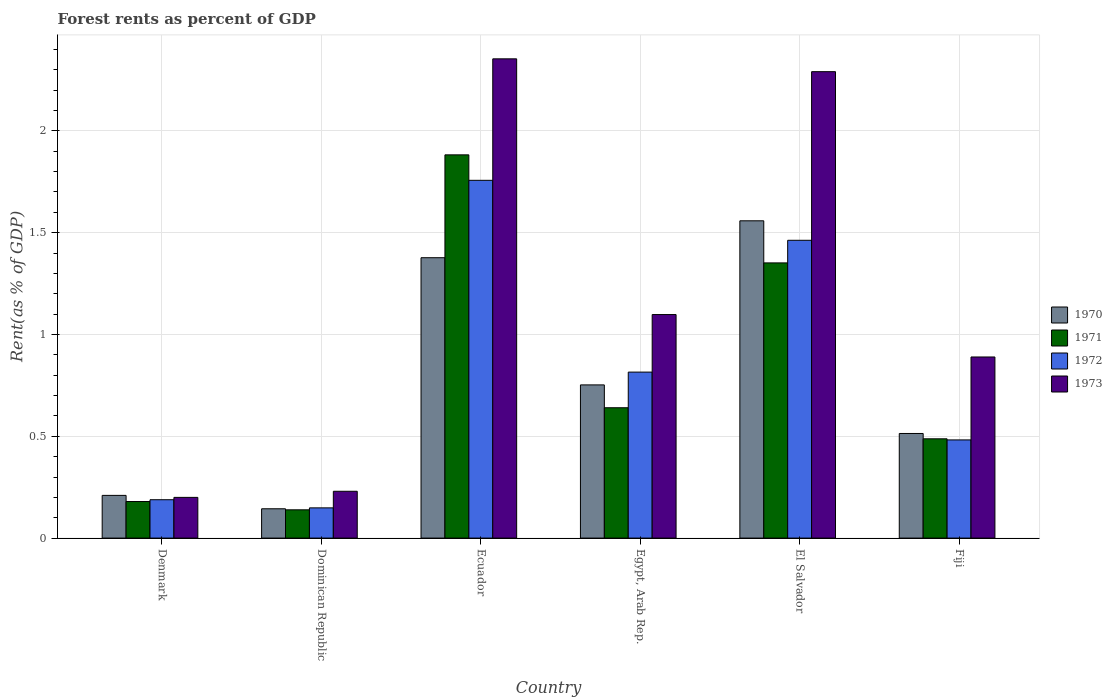How many different coloured bars are there?
Provide a succinct answer. 4. Are the number of bars per tick equal to the number of legend labels?
Provide a succinct answer. Yes. Are the number of bars on each tick of the X-axis equal?
Keep it short and to the point. Yes. How many bars are there on the 4th tick from the left?
Your response must be concise. 4. What is the label of the 3rd group of bars from the left?
Provide a short and direct response. Ecuador. What is the forest rent in 1970 in El Salvador?
Offer a very short reply. 1.56. Across all countries, what is the maximum forest rent in 1973?
Make the answer very short. 2.35. Across all countries, what is the minimum forest rent in 1972?
Give a very brief answer. 0.15. In which country was the forest rent in 1970 maximum?
Give a very brief answer. El Salvador. In which country was the forest rent in 1972 minimum?
Offer a terse response. Dominican Republic. What is the total forest rent in 1970 in the graph?
Provide a short and direct response. 4.56. What is the difference between the forest rent in 1973 in Dominican Republic and that in Fiji?
Keep it short and to the point. -0.66. What is the difference between the forest rent in 1973 in Denmark and the forest rent in 1970 in Egypt, Arab Rep.?
Offer a terse response. -0.55. What is the average forest rent in 1970 per country?
Keep it short and to the point. 0.76. What is the difference between the forest rent of/in 1970 and forest rent of/in 1971 in Ecuador?
Ensure brevity in your answer.  -0.51. In how many countries, is the forest rent in 1973 greater than 1.8 %?
Provide a short and direct response. 2. What is the ratio of the forest rent in 1970 in Ecuador to that in Fiji?
Give a very brief answer. 2.68. Is the difference between the forest rent in 1970 in Ecuador and Egypt, Arab Rep. greater than the difference between the forest rent in 1971 in Ecuador and Egypt, Arab Rep.?
Your answer should be compact. No. What is the difference between the highest and the second highest forest rent in 1971?
Provide a succinct answer. -1.24. What is the difference between the highest and the lowest forest rent in 1970?
Your answer should be compact. 1.41. In how many countries, is the forest rent in 1973 greater than the average forest rent in 1973 taken over all countries?
Offer a terse response. 2. Is the sum of the forest rent in 1970 in Denmark and Dominican Republic greater than the maximum forest rent in 1972 across all countries?
Make the answer very short. No. What does the 4th bar from the left in Denmark represents?
Your answer should be very brief. 1973. How many bars are there?
Your response must be concise. 24. How many countries are there in the graph?
Your answer should be very brief. 6. What is the difference between two consecutive major ticks on the Y-axis?
Give a very brief answer. 0.5. Does the graph contain any zero values?
Keep it short and to the point. No. Does the graph contain grids?
Provide a short and direct response. Yes. Where does the legend appear in the graph?
Offer a very short reply. Center right. How many legend labels are there?
Your answer should be compact. 4. How are the legend labels stacked?
Your answer should be very brief. Vertical. What is the title of the graph?
Your answer should be compact. Forest rents as percent of GDP. What is the label or title of the X-axis?
Your response must be concise. Country. What is the label or title of the Y-axis?
Provide a short and direct response. Rent(as % of GDP). What is the Rent(as % of GDP) in 1970 in Denmark?
Keep it short and to the point. 0.21. What is the Rent(as % of GDP) in 1971 in Denmark?
Keep it short and to the point. 0.18. What is the Rent(as % of GDP) of 1972 in Denmark?
Your answer should be very brief. 0.19. What is the Rent(as % of GDP) in 1973 in Denmark?
Offer a very short reply. 0.2. What is the Rent(as % of GDP) in 1970 in Dominican Republic?
Offer a very short reply. 0.14. What is the Rent(as % of GDP) of 1971 in Dominican Republic?
Offer a terse response. 0.14. What is the Rent(as % of GDP) in 1972 in Dominican Republic?
Provide a short and direct response. 0.15. What is the Rent(as % of GDP) of 1973 in Dominican Republic?
Provide a short and direct response. 0.23. What is the Rent(as % of GDP) of 1970 in Ecuador?
Offer a terse response. 1.38. What is the Rent(as % of GDP) in 1971 in Ecuador?
Make the answer very short. 1.88. What is the Rent(as % of GDP) in 1972 in Ecuador?
Offer a very short reply. 1.76. What is the Rent(as % of GDP) of 1973 in Ecuador?
Your answer should be very brief. 2.35. What is the Rent(as % of GDP) of 1970 in Egypt, Arab Rep.?
Your answer should be very brief. 0.75. What is the Rent(as % of GDP) of 1971 in Egypt, Arab Rep.?
Keep it short and to the point. 0.64. What is the Rent(as % of GDP) of 1972 in Egypt, Arab Rep.?
Keep it short and to the point. 0.82. What is the Rent(as % of GDP) in 1973 in Egypt, Arab Rep.?
Ensure brevity in your answer.  1.1. What is the Rent(as % of GDP) in 1970 in El Salvador?
Your answer should be compact. 1.56. What is the Rent(as % of GDP) of 1971 in El Salvador?
Provide a succinct answer. 1.35. What is the Rent(as % of GDP) in 1972 in El Salvador?
Your answer should be very brief. 1.46. What is the Rent(as % of GDP) in 1973 in El Salvador?
Offer a terse response. 2.29. What is the Rent(as % of GDP) in 1970 in Fiji?
Your response must be concise. 0.51. What is the Rent(as % of GDP) in 1971 in Fiji?
Provide a succinct answer. 0.49. What is the Rent(as % of GDP) of 1972 in Fiji?
Give a very brief answer. 0.48. What is the Rent(as % of GDP) in 1973 in Fiji?
Offer a terse response. 0.89. Across all countries, what is the maximum Rent(as % of GDP) of 1970?
Offer a terse response. 1.56. Across all countries, what is the maximum Rent(as % of GDP) of 1971?
Keep it short and to the point. 1.88. Across all countries, what is the maximum Rent(as % of GDP) of 1972?
Your response must be concise. 1.76. Across all countries, what is the maximum Rent(as % of GDP) of 1973?
Provide a short and direct response. 2.35. Across all countries, what is the minimum Rent(as % of GDP) of 1970?
Offer a terse response. 0.14. Across all countries, what is the minimum Rent(as % of GDP) in 1971?
Offer a very short reply. 0.14. Across all countries, what is the minimum Rent(as % of GDP) of 1972?
Make the answer very short. 0.15. Across all countries, what is the minimum Rent(as % of GDP) in 1973?
Keep it short and to the point. 0.2. What is the total Rent(as % of GDP) in 1970 in the graph?
Keep it short and to the point. 4.56. What is the total Rent(as % of GDP) in 1971 in the graph?
Offer a terse response. 4.68. What is the total Rent(as % of GDP) of 1972 in the graph?
Your answer should be very brief. 4.85. What is the total Rent(as % of GDP) in 1973 in the graph?
Ensure brevity in your answer.  7.06. What is the difference between the Rent(as % of GDP) in 1970 in Denmark and that in Dominican Republic?
Provide a short and direct response. 0.07. What is the difference between the Rent(as % of GDP) of 1971 in Denmark and that in Dominican Republic?
Your answer should be compact. 0.04. What is the difference between the Rent(as % of GDP) in 1972 in Denmark and that in Dominican Republic?
Give a very brief answer. 0.04. What is the difference between the Rent(as % of GDP) in 1973 in Denmark and that in Dominican Republic?
Give a very brief answer. -0.03. What is the difference between the Rent(as % of GDP) of 1970 in Denmark and that in Ecuador?
Your answer should be compact. -1.17. What is the difference between the Rent(as % of GDP) of 1971 in Denmark and that in Ecuador?
Provide a short and direct response. -1.7. What is the difference between the Rent(as % of GDP) of 1972 in Denmark and that in Ecuador?
Your response must be concise. -1.57. What is the difference between the Rent(as % of GDP) of 1973 in Denmark and that in Ecuador?
Your response must be concise. -2.15. What is the difference between the Rent(as % of GDP) in 1970 in Denmark and that in Egypt, Arab Rep.?
Provide a short and direct response. -0.54. What is the difference between the Rent(as % of GDP) of 1971 in Denmark and that in Egypt, Arab Rep.?
Ensure brevity in your answer.  -0.46. What is the difference between the Rent(as % of GDP) in 1972 in Denmark and that in Egypt, Arab Rep.?
Your answer should be very brief. -0.63. What is the difference between the Rent(as % of GDP) in 1973 in Denmark and that in Egypt, Arab Rep.?
Offer a terse response. -0.9. What is the difference between the Rent(as % of GDP) of 1970 in Denmark and that in El Salvador?
Provide a succinct answer. -1.35. What is the difference between the Rent(as % of GDP) in 1971 in Denmark and that in El Salvador?
Provide a succinct answer. -1.17. What is the difference between the Rent(as % of GDP) in 1972 in Denmark and that in El Salvador?
Your answer should be compact. -1.27. What is the difference between the Rent(as % of GDP) in 1973 in Denmark and that in El Salvador?
Your answer should be compact. -2.09. What is the difference between the Rent(as % of GDP) in 1970 in Denmark and that in Fiji?
Provide a short and direct response. -0.3. What is the difference between the Rent(as % of GDP) in 1971 in Denmark and that in Fiji?
Give a very brief answer. -0.31. What is the difference between the Rent(as % of GDP) in 1972 in Denmark and that in Fiji?
Offer a very short reply. -0.29. What is the difference between the Rent(as % of GDP) of 1973 in Denmark and that in Fiji?
Offer a very short reply. -0.69. What is the difference between the Rent(as % of GDP) of 1970 in Dominican Republic and that in Ecuador?
Give a very brief answer. -1.23. What is the difference between the Rent(as % of GDP) in 1971 in Dominican Republic and that in Ecuador?
Make the answer very short. -1.74. What is the difference between the Rent(as % of GDP) of 1972 in Dominican Republic and that in Ecuador?
Make the answer very short. -1.61. What is the difference between the Rent(as % of GDP) of 1973 in Dominican Republic and that in Ecuador?
Give a very brief answer. -2.12. What is the difference between the Rent(as % of GDP) of 1970 in Dominican Republic and that in Egypt, Arab Rep.?
Offer a terse response. -0.61. What is the difference between the Rent(as % of GDP) of 1971 in Dominican Republic and that in Egypt, Arab Rep.?
Offer a terse response. -0.5. What is the difference between the Rent(as % of GDP) of 1972 in Dominican Republic and that in Egypt, Arab Rep.?
Your response must be concise. -0.67. What is the difference between the Rent(as % of GDP) in 1973 in Dominican Republic and that in Egypt, Arab Rep.?
Offer a terse response. -0.87. What is the difference between the Rent(as % of GDP) of 1970 in Dominican Republic and that in El Salvador?
Your answer should be compact. -1.41. What is the difference between the Rent(as % of GDP) in 1971 in Dominican Republic and that in El Salvador?
Your answer should be compact. -1.21. What is the difference between the Rent(as % of GDP) in 1972 in Dominican Republic and that in El Salvador?
Ensure brevity in your answer.  -1.31. What is the difference between the Rent(as % of GDP) of 1973 in Dominican Republic and that in El Salvador?
Provide a short and direct response. -2.06. What is the difference between the Rent(as % of GDP) of 1970 in Dominican Republic and that in Fiji?
Provide a succinct answer. -0.37. What is the difference between the Rent(as % of GDP) in 1971 in Dominican Republic and that in Fiji?
Offer a terse response. -0.35. What is the difference between the Rent(as % of GDP) in 1972 in Dominican Republic and that in Fiji?
Your answer should be very brief. -0.33. What is the difference between the Rent(as % of GDP) in 1973 in Dominican Republic and that in Fiji?
Provide a short and direct response. -0.66. What is the difference between the Rent(as % of GDP) in 1970 in Ecuador and that in Egypt, Arab Rep.?
Your answer should be very brief. 0.62. What is the difference between the Rent(as % of GDP) of 1971 in Ecuador and that in Egypt, Arab Rep.?
Your answer should be compact. 1.24. What is the difference between the Rent(as % of GDP) of 1972 in Ecuador and that in Egypt, Arab Rep.?
Offer a terse response. 0.94. What is the difference between the Rent(as % of GDP) in 1973 in Ecuador and that in Egypt, Arab Rep.?
Make the answer very short. 1.26. What is the difference between the Rent(as % of GDP) of 1970 in Ecuador and that in El Salvador?
Provide a succinct answer. -0.18. What is the difference between the Rent(as % of GDP) in 1971 in Ecuador and that in El Salvador?
Offer a very short reply. 0.53. What is the difference between the Rent(as % of GDP) in 1972 in Ecuador and that in El Salvador?
Keep it short and to the point. 0.29. What is the difference between the Rent(as % of GDP) of 1973 in Ecuador and that in El Salvador?
Offer a very short reply. 0.06. What is the difference between the Rent(as % of GDP) of 1970 in Ecuador and that in Fiji?
Offer a very short reply. 0.86. What is the difference between the Rent(as % of GDP) of 1971 in Ecuador and that in Fiji?
Offer a terse response. 1.39. What is the difference between the Rent(as % of GDP) in 1972 in Ecuador and that in Fiji?
Your response must be concise. 1.28. What is the difference between the Rent(as % of GDP) of 1973 in Ecuador and that in Fiji?
Your response must be concise. 1.46. What is the difference between the Rent(as % of GDP) in 1970 in Egypt, Arab Rep. and that in El Salvador?
Provide a short and direct response. -0.81. What is the difference between the Rent(as % of GDP) in 1971 in Egypt, Arab Rep. and that in El Salvador?
Keep it short and to the point. -0.71. What is the difference between the Rent(as % of GDP) in 1972 in Egypt, Arab Rep. and that in El Salvador?
Give a very brief answer. -0.65. What is the difference between the Rent(as % of GDP) of 1973 in Egypt, Arab Rep. and that in El Salvador?
Keep it short and to the point. -1.19. What is the difference between the Rent(as % of GDP) of 1970 in Egypt, Arab Rep. and that in Fiji?
Your response must be concise. 0.24. What is the difference between the Rent(as % of GDP) in 1971 in Egypt, Arab Rep. and that in Fiji?
Offer a terse response. 0.15. What is the difference between the Rent(as % of GDP) in 1972 in Egypt, Arab Rep. and that in Fiji?
Give a very brief answer. 0.33. What is the difference between the Rent(as % of GDP) of 1973 in Egypt, Arab Rep. and that in Fiji?
Your answer should be very brief. 0.21. What is the difference between the Rent(as % of GDP) of 1970 in El Salvador and that in Fiji?
Give a very brief answer. 1.04. What is the difference between the Rent(as % of GDP) of 1971 in El Salvador and that in Fiji?
Give a very brief answer. 0.86. What is the difference between the Rent(as % of GDP) of 1972 in El Salvador and that in Fiji?
Ensure brevity in your answer.  0.98. What is the difference between the Rent(as % of GDP) of 1973 in El Salvador and that in Fiji?
Keep it short and to the point. 1.4. What is the difference between the Rent(as % of GDP) in 1970 in Denmark and the Rent(as % of GDP) in 1971 in Dominican Republic?
Your answer should be compact. 0.07. What is the difference between the Rent(as % of GDP) of 1970 in Denmark and the Rent(as % of GDP) of 1972 in Dominican Republic?
Make the answer very short. 0.06. What is the difference between the Rent(as % of GDP) of 1970 in Denmark and the Rent(as % of GDP) of 1973 in Dominican Republic?
Provide a succinct answer. -0.02. What is the difference between the Rent(as % of GDP) in 1971 in Denmark and the Rent(as % of GDP) in 1972 in Dominican Republic?
Your response must be concise. 0.03. What is the difference between the Rent(as % of GDP) in 1971 in Denmark and the Rent(as % of GDP) in 1973 in Dominican Republic?
Offer a terse response. -0.05. What is the difference between the Rent(as % of GDP) of 1972 in Denmark and the Rent(as % of GDP) of 1973 in Dominican Republic?
Your answer should be compact. -0.04. What is the difference between the Rent(as % of GDP) in 1970 in Denmark and the Rent(as % of GDP) in 1971 in Ecuador?
Offer a very short reply. -1.67. What is the difference between the Rent(as % of GDP) in 1970 in Denmark and the Rent(as % of GDP) in 1972 in Ecuador?
Provide a short and direct response. -1.55. What is the difference between the Rent(as % of GDP) in 1970 in Denmark and the Rent(as % of GDP) in 1973 in Ecuador?
Provide a succinct answer. -2.14. What is the difference between the Rent(as % of GDP) in 1971 in Denmark and the Rent(as % of GDP) in 1972 in Ecuador?
Offer a very short reply. -1.58. What is the difference between the Rent(as % of GDP) in 1971 in Denmark and the Rent(as % of GDP) in 1973 in Ecuador?
Keep it short and to the point. -2.17. What is the difference between the Rent(as % of GDP) of 1972 in Denmark and the Rent(as % of GDP) of 1973 in Ecuador?
Offer a terse response. -2.17. What is the difference between the Rent(as % of GDP) of 1970 in Denmark and the Rent(as % of GDP) of 1971 in Egypt, Arab Rep.?
Offer a very short reply. -0.43. What is the difference between the Rent(as % of GDP) of 1970 in Denmark and the Rent(as % of GDP) of 1972 in Egypt, Arab Rep.?
Ensure brevity in your answer.  -0.61. What is the difference between the Rent(as % of GDP) in 1970 in Denmark and the Rent(as % of GDP) in 1973 in Egypt, Arab Rep.?
Keep it short and to the point. -0.89. What is the difference between the Rent(as % of GDP) in 1971 in Denmark and the Rent(as % of GDP) in 1972 in Egypt, Arab Rep.?
Offer a very short reply. -0.64. What is the difference between the Rent(as % of GDP) in 1971 in Denmark and the Rent(as % of GDP) in 1973 in Egypt, Arab Rep.?
Provide a short and direct response. -0.92. What is the difference between the Rent(as % of GDP) of 1972 in Denmark and the Rent(as % of GDP) of 1973 in Egypt, Arab Rep.?
Provide a short and direct response. -0.91. What is the difference between the Rent(as % of GDP) in 1970 in Denmark and the Rent(as % of GDP) in 1971 in El Salvador?
Ensure brevity in your answer.  -1.14. What is the difference between the Rent(as % of GDP) in 1970 in Denmark and the Rent(as % of GDP) in 1972 in El Salvador?
Provide a succinct answer. -1.25. What is the difference between the Rent(as % of GDP) in 1970 in Denmark and the Rent(as % of GDP) in 1973 in El Salvador?
Offer a very short reply. -2.08. What is the difference between the Rent(as % of GDP) in 1971 in Denmark and the Rent(as % of GDP) in 1972 in El Salvador?
Your answer should be compact. -1.28. What is the difference between the Rent(as % of GDP) in 1971 in Denmark and the Rent(as % of GDP) in 1973 in El Salvador?
Provide a succinct answer. -2.11. What is the difference between the Rent(as % of GDP) in 1972 in Denmark and the Rent(as % of GDP) in 1973 in El Salvador?
Give a very brief answer. -2.1. What is the difference between the Rent(as % of GDP) in 1970 in Denmark and the Rent(as % of GDP) in 1971 in Fiji?
Keep it short and to the point. -0.28. What is the difference between the Rent(as % of GDP) of 1970 in Denmark and the Rent(as % of GDP) of 1972 in Fiji?
Make the answer very short. -0.27. What is the difference between the Rent(as % of GDP) of 1970 in Denmark and the Rent(as % of GDP) of 1973 in Fiji?
Your answer should be very brief. -0.68. What is the difference between the Rent(as % of GDP) in 1971 in Denmark and the Rent(as % of GDP) in 1972 in Fiji?
Your answer should be very brief. -0.3. What is the difference between the Rent(as % of GDP) in 1971 in Denmark and the Rent(as % of GDP) in 1973 in Fiji?
Make the answer very short. -0.71. What is the difference between the Rent(as % of GDP) of 1972 in Denmark and the Rent(as % of GDP) of 1973 in Fiji?
Make the answer very short. -0.7. What is the difference between the Rent(as % of GDP) of 1970 in Dominican Republic and the Rent(as % of GDP) of 1971 in Ecuador?
Offer a very short reply. -1.74. What is the difference between the Rent(as % of GDP) of 1970 in Dominican Republic and the Rent(as % of GDP) of 1972 in Ecuador?
Your answer should be compact. -1.61. What is the difference between the Rent(as % of GDP) of 1970 in Dominican Republic and the Rent(as % of GDP) of 1973 in Ecuador?
Provide a succinct answer. -2.21. What is the difference between the Rent(as % of GDP) of 1971 in Dominican Republic and the Rent(as % of GDP) of 1972 in Ecuador?
Your answer should be very brief. -1.62. What is the difference between the Rent(as % of GDP) of 1971 in Dominican Republic and the Rent(as % of GDP) of 1973 in Ecuador?
Give a very brief answer. -2.22. What is the difference between the Rent(as % of GDP) in 1972 in Dominican Republic and the Rent(as % of GDP) in 1973 in Ecuador?
Provide a short and direct response. -2.21. What is the difference between the Rent(as % of GDP) of 1970 in Dominican Republic and the Rent(as % of GDP) of 1971 in Egypt, Arab Rep.?
Offer a terse response. -0.5. What is the difference between the Rent(as % of GDP) in 1970 in Dominican Republic and the Rent(as % of GDP) in 1972 in Egypt, Arab Rep.?
Ensure brevity in your answer.  -0.67. What is the difference between the Rent(as % of GDP) in 1970 in Dominican Republic and the Rent(as % of GDP) in 1973 in Egypt, Arab Rep.?
Your response must be concise. -0.95. What is the difference between the Rent(as % of GDP) of 1971 in Dominican Republic and the Rent(as % of GDP) of 1972 in Egypt, Arab Rep.?
Give a very brief answer. -0.68. What is the difference between the Rent(as % of GDP) in 1971 in Dominican Republic and the Rent(as % of GDP) in 1973 in Egypt, Arab Rep.?
Offer a terse response. -0.96. What is the difference between the Rent(as % of GDP) of 1972 in Dominican Republic and the Rent(as % of GDP) of 1973 in Egypt, Arab Rep.?
Your response must be concise. -0.95. What is the difference between the Rent(as % of GDP) in 1970 in Dominican Republic and the Rent(as % of GDP) in 1971 in El Salvador?
Provide a short and direct response. -1.21. What is the difference between the Rent(as % of GDP) in 1970 in Dominican Republic and the Rent(as % of GDP) in 1972 in El Salvador?
Provide a succinct answer. -1.32. What is the difference between the Rent(as % of GDP) in 1970 in Dominican Republic and the Rent(as % of GDP) in 1973 in El Salvador?
Make the answer very short. -2.15. What is the difference between the Rent(as % of GDP) of 1971 in Dominican Republic and the Rent(as % of GDP) of 1972 in El Salvador?
Provide a succinct answer. -1.32. What is the difference between the Rent(as % of GDP) of 1971 in Dominican Republic and the Rent(as % of GDP) of 1973 in El Salvador?
Provide a succinct answer. -2.15. What is the difference between the Rent(as % of GDP) in 1972 in Dominican Republic and the Rent(as % of GDP) in 1973 in El Salvador?
Your answer should be compact. -2.14. What is the difference between the Rent(as % of GDP) of 1970 in Dominican Republic and the Rent(as % of GDP) of 1971 in Fiji?
Offer a terse response. -0.34. What is the difference between the Rent(as % of GDP) of 1970 in Dominican Republic and the Rent(as % of GDP) of 1972 in Fiji?
Provide a succinct answer. -0.34. What is the difference between the Rent(as % of GDP) in 1970 in Dominican Republic and the Rent(as % of GDP) in 1973 in Fiji?
Provide a succinct answer. -0.75. What is the difference between the Rent(as % of GDP) of 1971 in Dominican Republic and the Rent(as % of GDP) of 1972 in Fiji?
Provide a succinct answer. -0.34. What is the difference between the Rent(as % of GDP) of 1971 in Dominican Republic and the Rent(as % of GDP) of 1973 in Fiji?
Offer a terse response. -0.75. What is the difference between the Rent(as % of GDP) of 1972 in Dominican Republic and the Rent(as % of GDP) of 1973 in Fiji?
Ensure brevity in your answer.  -0.74. What is the difference between the Rent(as % of GDP) in 1970 in Ecuador and the Rent(as % of GDP) in 1971 in Egypt, Arab Rep.?
Give a very brief answer. 0.74. What is the difference between the Rent(as % of GDP) in 1970 in Ecuador and the Rent(as % of GDP) in 1972 in Egypt, Arab Rep.?
Provide a short and direct response. 0.56. What is the difference between the Rent(as % of GDP) in 1970 in Ecuador and the Rent(as % of GDP) in 1973 in Egypt, Arab Rep.?
Your response must be concise. 0.28. What is the difference between the Rent(as % of GDP) in 1971 in Ecuador and the Rent(as % of GDP) in 1972 in Egypt, Arab Rep.?
Your response must be concise. 1.07. What is the difference between the Rent(as % of GDP) in 1971 in Ecuador and the Rent(as % of GDP) in 1973 in Egypt, Arab Rep.?
Offer a terse response. 0.78. What is the difference between the Rent(as % of GDP) of 1972 in Ecuador and the Rent(as % of GDP) of 1973 in Egypt, Arab Rep.?
Your response must be concise. 0.66. What is the difference between the Rent(as % of GDP) in 1970 in Ecuador and the Rent(as % of GDP) in 1971 in El Salvador?
Your answer should be compact. 0.03. What is the difference between the Rent(as % of GDP) in 1970 in Ecuador and the Rent(as % of GDP) in 1972 in El Salvador?
Make the answer very short. -0.09. What is the difference between the Rent(as % of GDP) in 1970 in Ecuador and the Rent(as % of GDP) in 1973 in El Salvador?
Ensure brevity in your answer.  -0.91. What is the difference between the Rent(as % of GDP) of 1971 in Ecuador and the Rent(as % of GDP) of 1972 in El Salvador?
Your response must be concise. 0.42. What is the difference between the Rent(as % of GDP) of 1971 in Ecuador and the Rent(as % of GDP) of 1973 in El Salvador?
Offer a very short reply. -0.41. What is the difference between the Rent(as % of GDP) in 1972 in Ecuador and the Rent(as % of GDP) in 1973 in El Salvador?
Ensure brevity in your answer.  -0.53. What is the difference between the Rent(as % of GDP) in 1970 in Ecuador and the Rent(as % of GDP) in 1971 in Fiji?
Offer a terse response. 0.89. What is the difference between the Rent(as % of GDP) in 1970 in Ecuador and the Rent(as % of GDP) in 1972 in Fiji?
Offer a very short reply. 0.89. What is the difference between the Rent(as % of GDP) of 1970 in Ecuador and the Rent(as % of GDP) of 1973 in Fiji?
Your response must be concise. 0.49. What is the difference between the Rent(as % of GDP) of 1971 in Ecuador and the Rent(as % of GDP) of 1972 in Fiji?
Your answer should be compact. 1.4. What is the difference between the Rent(as % of GDP) in 1972 in Ecuador and the Rent(as % of GDP) in 1973 in Fiji?
Your response must be concise. 0.87. What is the difference between the Rent(as % of GDP) in 1970 in Egypt, Arab Rep. and the Rent(as % of GDP) in 1971 in El Salvador?
Give a very brief answer. -0.6. What is the difference between the Rent(as % of GDP) of 1970 in Egypt, Arab Rep. and the Rent(as % of GDP) of 1972 in El Salvador?
Offer a terse response. -0.71. What is the difference between the Rent(as % of GDP) in 1970 in Egypt, Arab Rep. and the Rent(as % of GDP) in 1973 in El Salvador?
Provide a short and direct response. -1.54. What is the difference between the Rent(as % of GDP) in 1971 in Egypt, Arab Rep. and the Rent(as % of GDP) in 1972 in El Salvador?
Give a very brief answer. -0.82. What is the difference between the Rent(as % of GDP) in 1971 in Egypt, Arab Rep. and the Rent(as % of GDP) in 1973 in El Salvador?
Ensure brevity in your answer.  -1.65. What is the difference between the Rent(as % of GDP) in 1972 in Egypt, Arab Rep. and the Rent(as % of GDP) in 1973 in El Salvador?
Make the answer very short. -1.48. What is the difference between the Rent(as % of GDP) of 1970 in Egypt, Arab Rep. and the Rent(as % of GDP) of 1971 in Fiji?
Your response must be concise. 0.26. What is the difference between the Rent(as % of GDP) of 1970 in Egypt, Arab Rep. and the Rent(as % of GDP) of 1972 in Fiji?
Make the answer very short. 0.27. What is the difference between the Rent(as % of GDP) of 1970 in Egypt, Arab Rep. and the Rent(as % of GDP) of 1973 in Fiji?
Keep it short and to the point. -0.14. What is the difference between the Rent(as % of GDP) in 1971 in Egypt, Arab Rep. and the Rent(as % of GDP) in 1972 in Fiji?
Provide a short and direct response. 0.16. What is the difference between the Rent(as % of GDP) in 1971 in Egypt, Arab Rep. and the Rent(as % of GDP) in 1973 in Fiji?
Give a very brief answer. -0.25. What is the difference between the Rent(as % of GDP) in 1972 in Egypt, Arab Rep. and the Rent(as % of GDP) in 1973 in Fiji?
Offer a very short reply. -0.07. What is the difference between the Rent(as % of GDP) in 1970 in El Salvador and the Rent(as % of GDP) in 1971 in Fiji?
Provide a succinct answer. 1.07. What is the difference between the Rent(as % of GDP) in 1970 in El Salvador and the Rent(as % of GDP) in 1972 in Fiji?
Make the answer very short. 1.08. What is the difference between the Rent(as % of GDP) in 1970 in El Salvador and the Rent(as % of GDP) in 1973 in Fiji?
Make the answer very short. 0.67. What is the difference between the Rent(as % of GDP) of 1971 in El Salvador and the Rent(as % of GDP) of 1972 in Fiji?
Give a very brief answer. 0.87. What is the difference between the Rent(as % of GDP) in 1971 in El Salvador and the Rent(as % of GDP) in 1973 in Fiji?
Your answer should be very brief. 0.46. What is the difference between the Rent(as % of GDP) of 1972 in El Salvador and the Rent(as % of GDP) of 1973 in Fiji?
Ensure brevity in your answer.  0.57. What is the average Rent(as % of GDP) in 1970 per country?
Provide a succinct answer. 0.76. What is the average Rent(as % of GDP) of 1971 per country?
Provide a succinct answer. 0.78. What is the average Rent(as % of GDP) in 1972 per country?
Ensure brevity in your answer.  0.81. What is the average Rent(as % of GDP) of 1973 per country?
Keep it short and to the point. 1.18. What is the difference between the Rent(as % of GDP) of 1970 and Rent(as % of GDP) of 1971 in Denmark?
Your response must be concise. 0.03. What is the difference between the Rent(as % of GDP) of 1970 and Rent(as % of GDP) of 1972 in Denmark?
Provide a short and direct response. 0.02. What is the difference between the Rent(as % of GDP) of 1970 and Rent(as % of GDP) of 1973 in Denmark?
Provide a succinct answer. 0.01. What is the difference between the Rent(as % of GDP) of 1971 and Rent(as % of GDP) of 1972 in Denmark?
Your response must be concise. -0.01. What is the difference between the Rent(as % of GDP) in 1971 and Rent(as % of GDP) in 1973 in Denmark?
Provide a succinct answer. -0.02. What is the difference between the Rent(as % of GDP) of 1972 and Rent(as % of GDP) of 1973 in Denmark?
Your response must be concise. -0.01. What is the difference between the Rent(as % of GDP) of 1970 and Rent(as % of GDP) of 1971 in Dominican Republic?
Provide a short and direct response. 0.01. What is the difference between the Rent(as % of GDP) in 1970 and Rent(as % of GDP) in 1972 in Dominican Republic?
Offer a terse response. -0. What is the difference between the Rent(as % of GDP) of 1970 and Rent(as % of GDP) of 1973 in Dominican Republic?
Provide a succinct answer. -0.09. What is the difference between the Rent(as % of GDP) in 1971 and Rent(as % of GDP) in 1972 in Dominican Republic?
Give a very brief answer. -0.01. What is the difference between the Rent(as % of GDP) of 1971 and Rent(as % of GDP) of 1973 in Dominican Republic?
Your response must be concise. -0.09. What is the difference between the Rent(as % of GDP) of 1972 and Rent(as % of GDP) of 1973 in Dominican Republic?
Offer a terse response. -0.08. What is the difference between the Rent(as % of GDP) in 1970 and Rent(as % of GDP) in 1971 in Ecuador?
Provide a short and direct response. -0.51. What is the difference between the Rent(as % of GDP) in 1970 and Rent(as % of GDP) in 1972 in Ecuador?
Ensure brevity in your answer.  -0.38. What is the difference between the Rent(as % of GDP) in 1970 and Rent(as % of GDP) in 1973 in Ecuador?
Offer a terse response. -0.98. What is the difference between the Rent(as % of GDP) in 1971 and Rent(as % of GDP) in 1973 in Ecuador?
Keep it short and to the point. -0.47. What is the difference between the Rent(as % of GDP) in 1972 and Rent(as % of GDP) in 1973 in Ecuador?
Make the answer very short. -0.6. What is the difference between the Rent(as % of GDP) of 1970 and Rent(as % of GDP) of 1971 in Egypt, Arab Rep.?
Your answer should be compact. 0.11. What is the difference between the Rent(as % of GDP) in 1970 and Rent(as % of GDP) in 1972 in Egypt, Arab Rep.?
Your answer should be very brief. -0.06. What is the difference between the Rent(as % of GDP) in 1970 and Rent(as % of GDP) in 1973 in Egypt, Arab Rep.?
Provide a succinct answer. -0.35. What is the difference between the Rent(as % of GDP) of 1971 and Rent(as % of GDP) of 1972 in Egypt, Arab Rep.?
Provide a short and direct response. -0.18. What is the difference between the Rent(as % of GDP) of 1971 and Rent(as % of GDP) of 1973 in Egypt, Arab Rep.?
Your answer should be very brief. -0.46. What is the difference between the Rent(as % of GDP) in 1972 and Rent(as % of GDP) in 1973 in Egypt, Arab Rep.?
Keep it short and to the point. -0.28. What is the difference between the Rent(as % of GDP) in 1970 and Rent(as % of GDP) in 1971 in El Salvador?
Offer a terse response. 0.21. What is the difference between the Rent(as % of GDP) of 1970 and Rent(as % of GDP) of 1972 in El Salvador?
Your response must be concise. 0.1. What is the difference between the Rent(as % of GDP) in 1970 and Rent(as % of GDP) in 1973 in El Salvador?
Give a very brief answer. -0.73. What is the difference between the Rent(as % of GDP) in 1971 and Rent(as % of GDP) in 1972 in El Salvador?
Give a very brief answer. -0.11. What is the difference between the Rent(as % of GDP) in 1971 and Rent(as % of GDP) in 1973 in El Salvador?
Give a very brief answer. -0.94. What is the difference between the Rent(as % of GDP) in 1972 and Rent(as % of GDP) in 1973 in El Salvador?
Offer a terse response. -0.83. What is the difference between the Rent(as % of GDP) of 1970 and Rent(as % of GDP) of 1971 in Fiji?
Make the answer very short. 0.03. What is the difference between the Rent(as % of GDP) of 1970 and Rent(as % of GDP) of 1972 in Fiji?
Ensure brevity in your answer.  0.03. What is the difference between the Rent(as % of GDP) in 1970 and Rent(as % of GDP) in 1973 in Fiji?
Offer a terse response. -0.38. What is the difference between the Rent(as % of GDP) of 1971 and Rent(as % of GDP) of 1972 in Fiji?
Ensure brevity in your answer.  0.01. What is the difference between the Rent(as % of GDP) of 1971 and Rent(as % of GDP) of 1973 in Fiji?
Your response must be concise. -0.4. What is the difference between the Rent(as % of GDP) in 1972 and Rent(as % of GDP) in 1973 in Fiji?
Offer a very short reply. -0.41. What is the ratio of the Rent(as % of GDP) of 1970 in Denmark to that in Dominican Republic?
Keep it short and to the point. 1.46. What is the ratio of the Rent(as % of GDP) of 1971 in Denmark to that in Dominican Republic?
Your response must be concise. 1.29. What is the ratio of the Rent(as % of GDP) in 1972 in Denmark to that in Dominican Republic?
Make the answer very short. 1.27. What is the ratio of the Rent(as % of GDP) of 1973 in Denmark to that in Dominican Republic?
Your response must be concise. 0.87. What is the ratio of the Rent(as % of GDP) in 1970 in Denmark to that in Ecuador?
Make the answer very short. 0.15. What is the ratio of the Rent(as % of GDP) of 1971 in Denmark to that in Ecuador?
Offer a very short reply. 0.1. What is the ratio of the Rent(as % of GDP) in 1972 in Denmark to that in Ecuador?
Keep it short and to the point. 0.11. What is the ratio of the Rent(as % of GDP) of 1973 in Denmark to that in Ecuador?
Make the answer very short. 0.08. What is the ratio of the Rent(as % of GDP) of 1970 in Denmark to that in Egypt, Arab Rep.?
Your response must be concise. 0.28. What is the ratio of the Rent(as % of GDP) in 1971 in Denmark to that in Egypt, Arab Rep.?
Offer a very short reply. 0.28. What is the ratio of the Rent(as % of GDP) in 1972 in Denmark to that in Egypt, Arab Rep.?
Keep it short and to the point. 0.23. What is the ratio of the Rent(as % of GDP) in 1973 in Denmark to that in Egypt, Arab Rep.?
Your answer should be compact. 0.18. What is the ratio of the Rent(as % of GDP) in 1970 in Denmark to that in El Salvador?
Keep it short and to the point. 0.13. What is the ratio of the Rent(as % of GDP) of 1971 in Denmark to that in El Salvador?
Provide a succinct answer. 0.13. What is the ratio of the Rent(as % of GDP) in 1972 in Denmark to that in El Salvador?
Offer a very short reply. 0.13. What is the ratio of the Rent(as % of GDP) of 1973 in Denmark to that in El Salvador?
Offer a very short reply. 0.09. What is the ratio of the Rent(as % of GDP) of 1970 in Denmark to that in Fiji?
Your answer should be very brief. 0.41. What is the ratio of the Rent(as % of GDP) of 1971 in Denmark to that in Fiji?
Make the answer very short. 0.37. What is the ratio of the Rent(as % of GDP) of 1972 in Denmark to that in Fiji?
Ensure brevity in your answer.  0.39. What is the ratio of the Rent(as % of GDP) in 1973 in Denmark to that in Fiji?
Keep it short and to the point. 0.22. What is the ratio of the Rent(as % of GDP) of 1970 in Dominican Republic to that in Ecuador?
Provide a short and direct response. 0.1. What is the ratio of the Rent(as % of GDP) in 1971 in Dominican Republic to that in Ecuador?
Provide a succinct answer. 0.07. What is the ratio of the Rent(as % of GDP) in 1972 in Dominican Republic to that in Ecuador?
Offer a terse response. 0.08. What is the ratio of the Rent(as % of GDP) of 1973 in Dominican Republic to that in Ecuador?
Your answer should be compact. 0.1. What is the ratio of the Rent(as % of GDP) of 1970 in Dominican Republic to that in Egypt, Arab Rep.?
Ensure brevity in your answer.  0.19. What is the ratio of the Rent(as % of GDP) in 1971 in Dominican Republic to that in Egypt, Arab Rep.?
Provide a short and direct response. 0.22. What is the ratio of the Rent(as % of GDP) in 1972 in Dominican Republic to that in Egypt, Arab Rep.?
Give a very brief answer. 0.18. What is the ratio of the Rent(as % of GDP) in 1973 in Dominican Republic to that in Egypt, Arab Rep.?
Keep it short and to the point. 0.21. What is the ratio of the Rent(as % of GDP) in 1970 in Dominican Republic to that in El Salvador?
Offer a terse response. 0.09. What is the ratio of the Rent(as % of GDP) of 1971 in Dominican Republic to that in El Salvador?
Your response must be concise. 0.1. What is the ratio of the Rent(as % of GDP) of 1972 in Dominican Republic to that in El Salvador?
Ensure brevity in your answer.  0.1. What is the ratio of the Rent(as % of GDP) in 1973 in Dominican Republic to that in El Salvador?
Provide a succinct answer. 0.1. What is the ratio of the Rent(as % of GDP) of 1970 in Dominican Republic to that in Fiji?
Provide a succinct answer. 0.28. What is the ratio of the Rent(as % of GDP) in 1971 in Dominican Republic to that in Fiji?
Ensure brevity in your answer.  0.28. What is the ratio of the Rent(as % of GDP) in 1972 in Dominican Republic to that in Fiji?
Offer a terse response. 0.31. What is the ratio of the Rent(as % of GDP) in 1973 in Dominican Republic to that in Fiji?
Your answer should be very brief. 0.26. What is the ratio of the Rent(as % of GDP) of 1970 in Ecuador to that in Egypt, Arab Rep.?
Make the answer very short. 1.83. What is the ratio of the Rent(as % of GDP) of 1971 in Ecuador to that in Egypt, Arab Rep.?
Ensure brevity in your answer.  2.94. What is the ratio of the Rent(as % of GDP) in 1972 in Ecuador to that in Egypt, Arab Rep.?
Ensure brevity in your answer.  2.16. What is the ratio of the Rent(as % of GDP) of 1973 in Ecuador to that in Egypt, Arab Rep.?
Keep it short and to the point. 2.14. What is the ratio of the Rent(as % of GDP) in 1970 in Ecuador to that in El Salvador?
Provide a succinct answer. 0.88. What is the ratio of the Rent(as % of GDP) of 1971 in Ecuador to that in El Salvador?
Keep it short and to the point. 1.39. What is the ratio of the Rent(as % of GDP) in 1972 in Ecuador to that in El Salvador?
Offer a very short reply. 1.2. What is the ratio of the Rent(as % of GDP) of 1973 in Ecuador to that in El Salvador?
Your response must be concise. 1.03. What is the ratio of the Rent(as % of GDP) of 1970 in Ecuador to that in Fiji?
Offer a terse response. 2.68. What is the ratio of the Rent(as % of GDP) in 1971 in Ecuador to that in Fiji?
Provide a short and direct response. 3.86. What is the ratio of the Rent(as % of GDP) in 1972 in Ecuador to that in Fiji?
Provide a succinct answer. 3.64. What is the ratio of the Rent(as % of GDP) of 1973 in Ecuador to that in Fiji?
Ensure brevity in your answer.  2.65. What is the ratio of the Rent(as % of GDP) of 1970 in Egypt, Arab Rep. to that in El Salvador?
Provide a succinct answer. 0.48. What is the ratio of the Rent(as % of GDP) of 1971 in Egypt, Arab Rep. to that in El Salvador?
Make the answer very short. 0.47. What is the ratio of the Rent(as % of GDP) of 1972 in Egypt, Arab Rep. to that in El Salvador?
Keep it short and to the point. 0.56. What is the ratio of the Rent(as % of GDP) of 1973 in Egypt, Arab Rep. to that in El Salvador?
Your answer should be compact. 0.48. What is the ratio of the Rent(as % of GDP) of 1970 in Egypt, Arab Rep. to that in Fiji?
Your response must be concise. 1.46. What is the ratio of the Rent(as % of GDP) in 1971 in Egypt, Arab Rep. to that in Fiji?
Offer a terse response. 1.31. What is the ratio of the Rent(as % of GDP) of 1972 in Egypt, Arab Rep. to that in Fiji?
Your answer should be very brief. 1.69. What is the ratio of the Rent(as % of GDP) in 1973 in Egypt, Arab Rep. to that in Fiji?
Give a very brief answer. 1.23. What is the ratio of the Rent(as % of GDP) of 1970 in El Salvador to that in Fiji?
Provide a short and direct response. 3.03. What is the ratio of the Rent(as % of GDP) in 1971 in El Salvador to that in Fiji?
Make the answer very short. 2.77. What is the ratio of the Rent(as % of GDP) of 1972 in El Salvador to that in Fiji?
Your response must be concise. 3.03. What is the ratio of the Rent(as % of GDP) in 1973 in El Salvador to that in Fiji?
Ensure brevity in your answer.  2.58. What is the difference between the highest and the second highest Rent(as % of GDP) of 1970?
Your response must be concise. 0.18. What is the difference between the highest and the second highest Rent(as % of GDP) in 1971?
Give a very brief answer. 0.53. What is the difference between the highest and the second highest Rent(as % of GDP) of 1972?
Give a very brief answer. 0.29. What is the difference between the highest and the second highest Rent(as % of GDP) in 1973?
Your response must be concise. 0.06. What is the difference between the highest and the lowest Rent(as % of GDP) of 1970?
Give a very brief answer. 1.41. What is the difference between the highest and the lowest Rent(as % of GDP) in 1971?
Your answer should be very brief. 1.74. What is the difference between the highest and the lowest Rent(as % of GDP) of 1972?
Your answer should be compact. 1.61. What is the difference between the highest and the lowest Rent(as % of GDP) in 1973?
Provide a succinct answer. 2.15. 